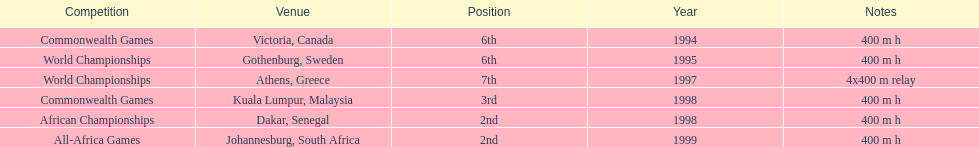How long was the relay at the 1997 world championships that ken harden ran 4x400 m relay. 